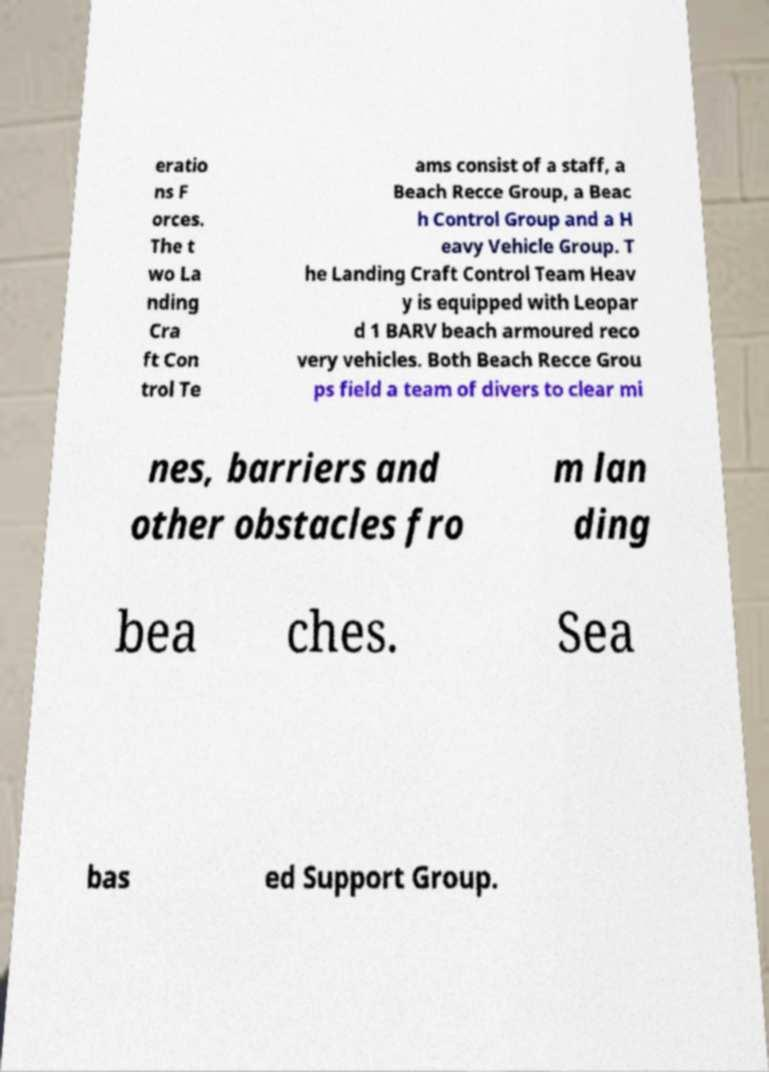Could you assist in decoding the text presented in this image and type it out clearly? eratio ns F orces. The t wo La nding Cra ft Con trol Te ams consist of a staff, a Beach Recce Group, a Beac h Control Group and a H eavy Vehicle Group. T he Landing Craft Control Team Heav y is equipped with Leopar d 1 BARV beach armoured reco very vehicles. Both Beach Recce Grou ps field a team of divers to clear mi nes, barriers and other obstacles fro m lan ding bea ches. Sea bas ed Support Group. 